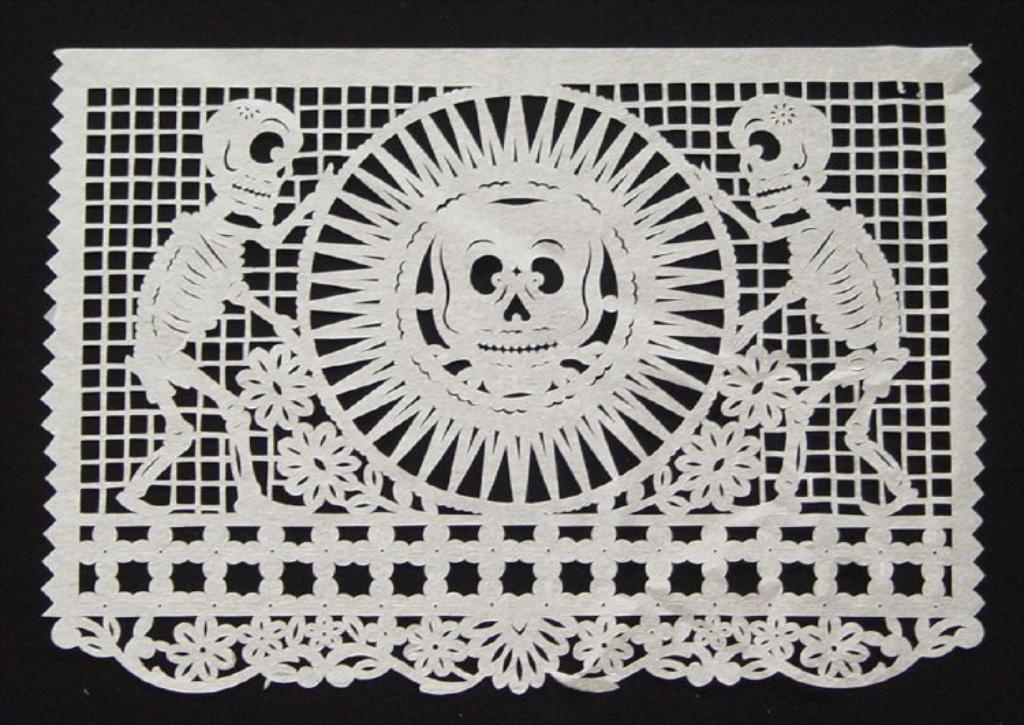What is the main subject of the image? The image contains a design. Can you describe the design in the image? The design contains human skeletons. How many sisters does the person in the image have? There is no person in the image, and therefore no information about any sisters. 